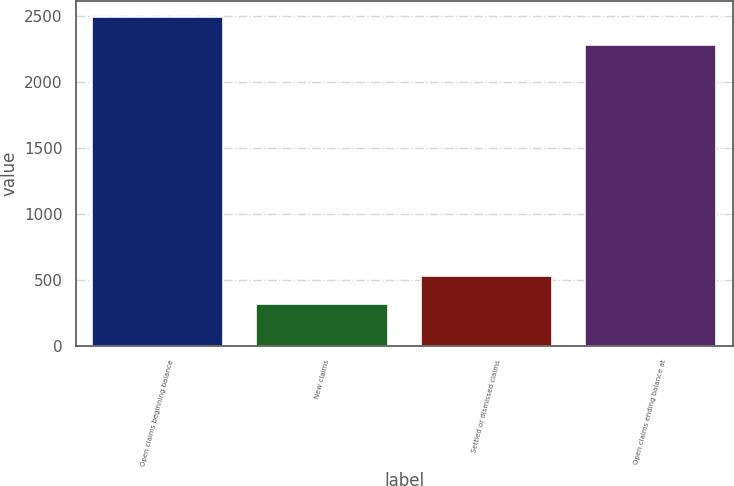Convert chart. <chart><loc_0><loc_0><loc_500><loc_500><bar_chart><fcel>Open claims beginning balance<fcel>New claims<fcel>Settled or dismissed claims<fcel>Open claims ending balance at<nl><fcel>2488.9<fcel>316<fcel>527.9<fcel>2277<nl></chart> 